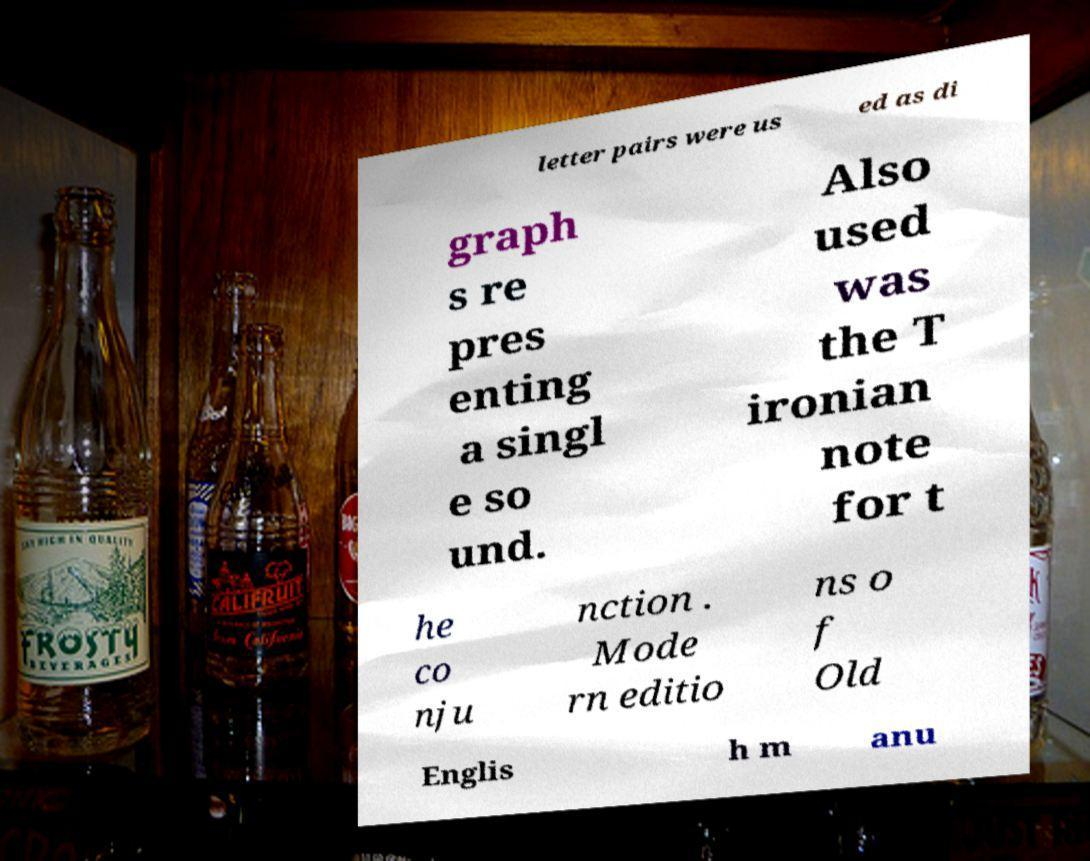What messages or text are displayed in this image? I need them in a readable, typed format. letter pairs were us ed as di graph s re pres enting a singl e so und. Also used was the T ironian note for t he co nju nction . Mode rn editio ns o f Old Englis h m anu 